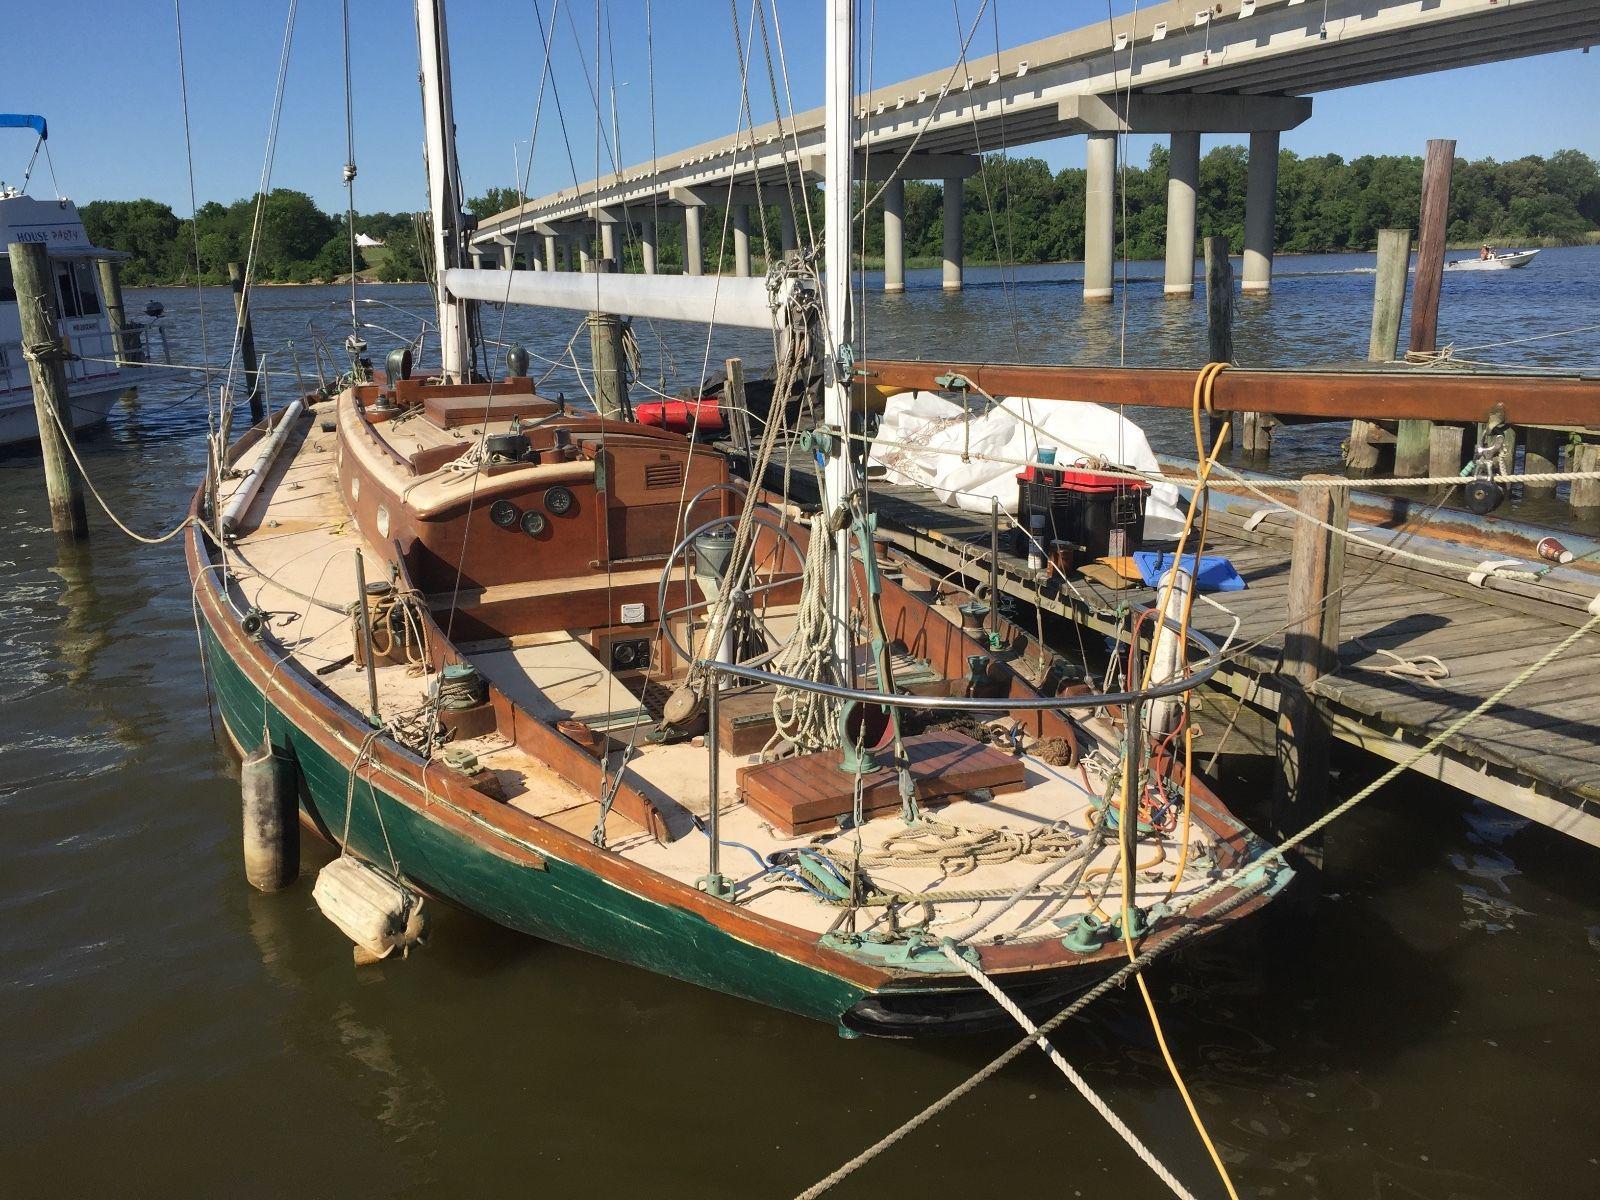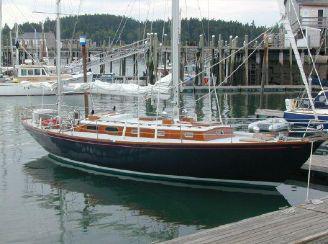The first image is the image on the left, the second image is the image on the right. Considering the images on both sides, is "There are three white sails up on the boat in the image on the left." valid? Answer yes or no. No. The first image is the image on the left, the second image is the image on the right. Examine the images to the left and right. Is the description "A sailboat with three unfurled sails in moving through open water with a man wearing a red coat riding at the back." accurate? Answer yes or no. No. 